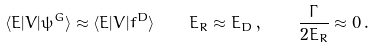Convert formula to latex. <formula><loc_0><loc_0><loc_500><loc_500>\langle E | V | \psi ^ { G } \rangle \approx \langle E | V | f ^ { D } \rangle \quad E _ { R } \approx E _ { D } \, , \quad \frac { \Gamma } { 2 E _ { R } } \approx 0 \, .</formula> 